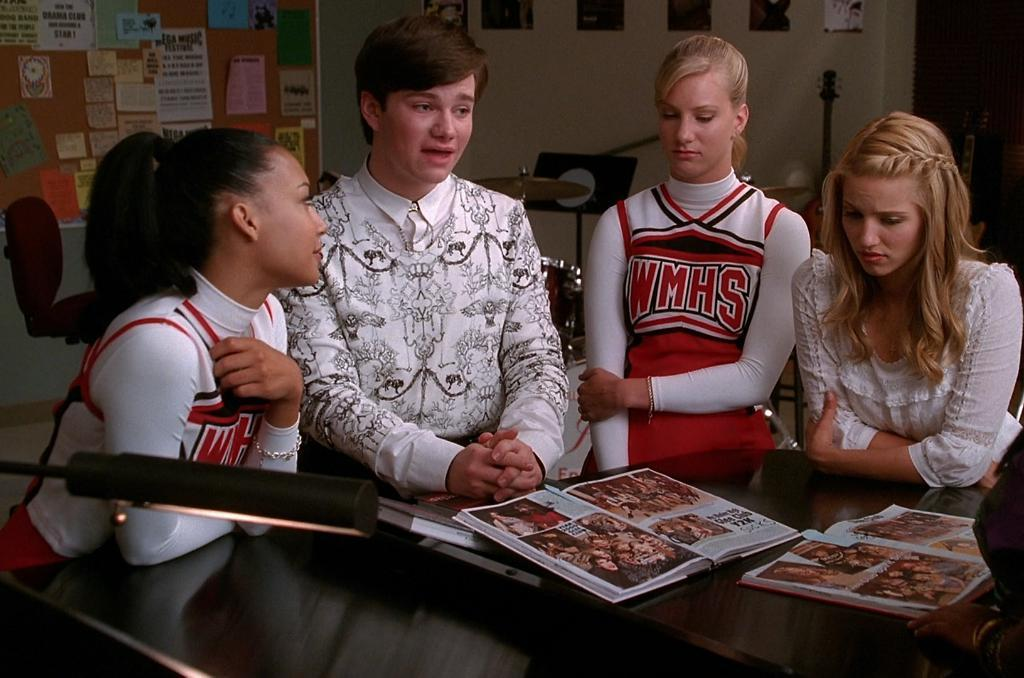<image>
Describe the image concisely. Two cheerleaders from WMHS sit with their friends. 